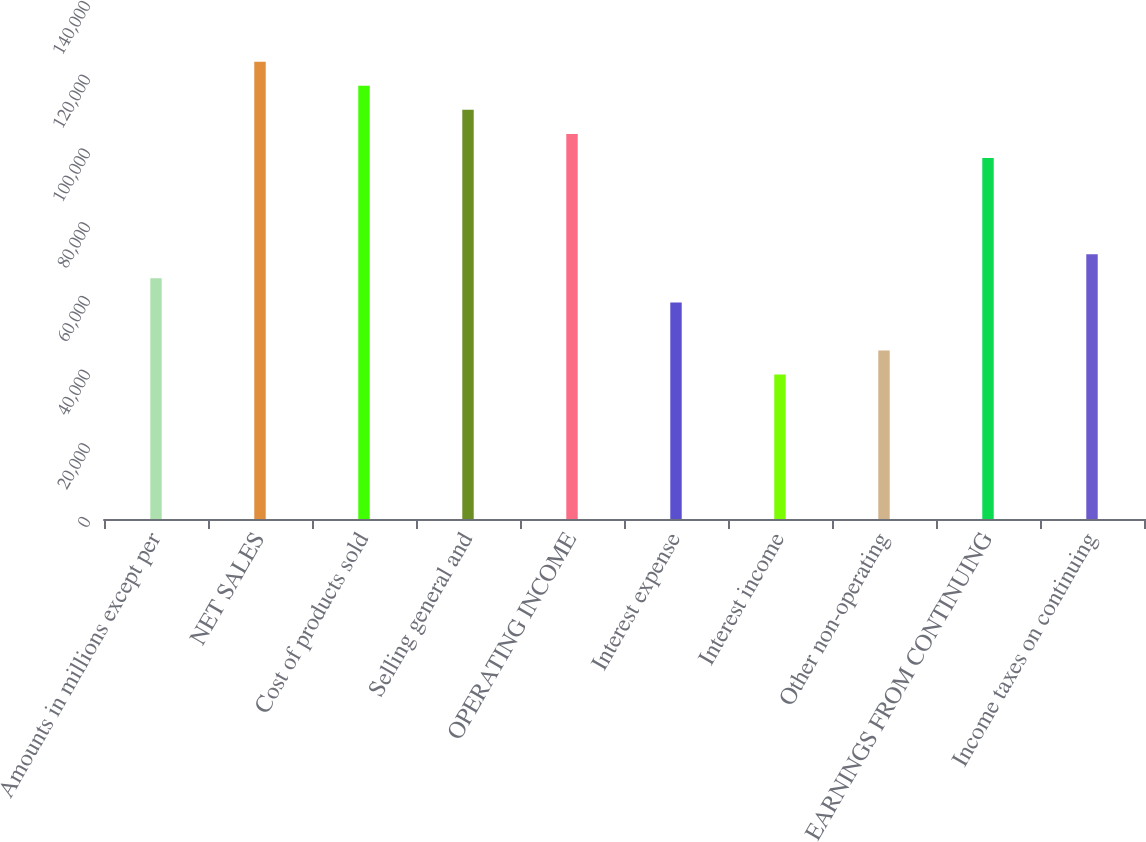<chart> <loc_0><loc_0><loc_500><loc_500><bar_chart><fcel>Amounts in millions except per<fcel>NET SALES<fcel>Cost of products sold<fcel>Selling general and<fcel>OPERATING INCOME<fcel>Interest expense<fcel>Interest income<fcel>Other non-operating<fcel>EARNINGS FROM CONTINUING<fcel>Income taxes on continuing<nl><fcel>65299<fcel>124068<fcel>117538<fcel>111008<fcel>104478<fcel>58769.1<fcel>39179.5<fcel>45709.4<fcel>97948.4<fcel>71828.9<nl></chart> 